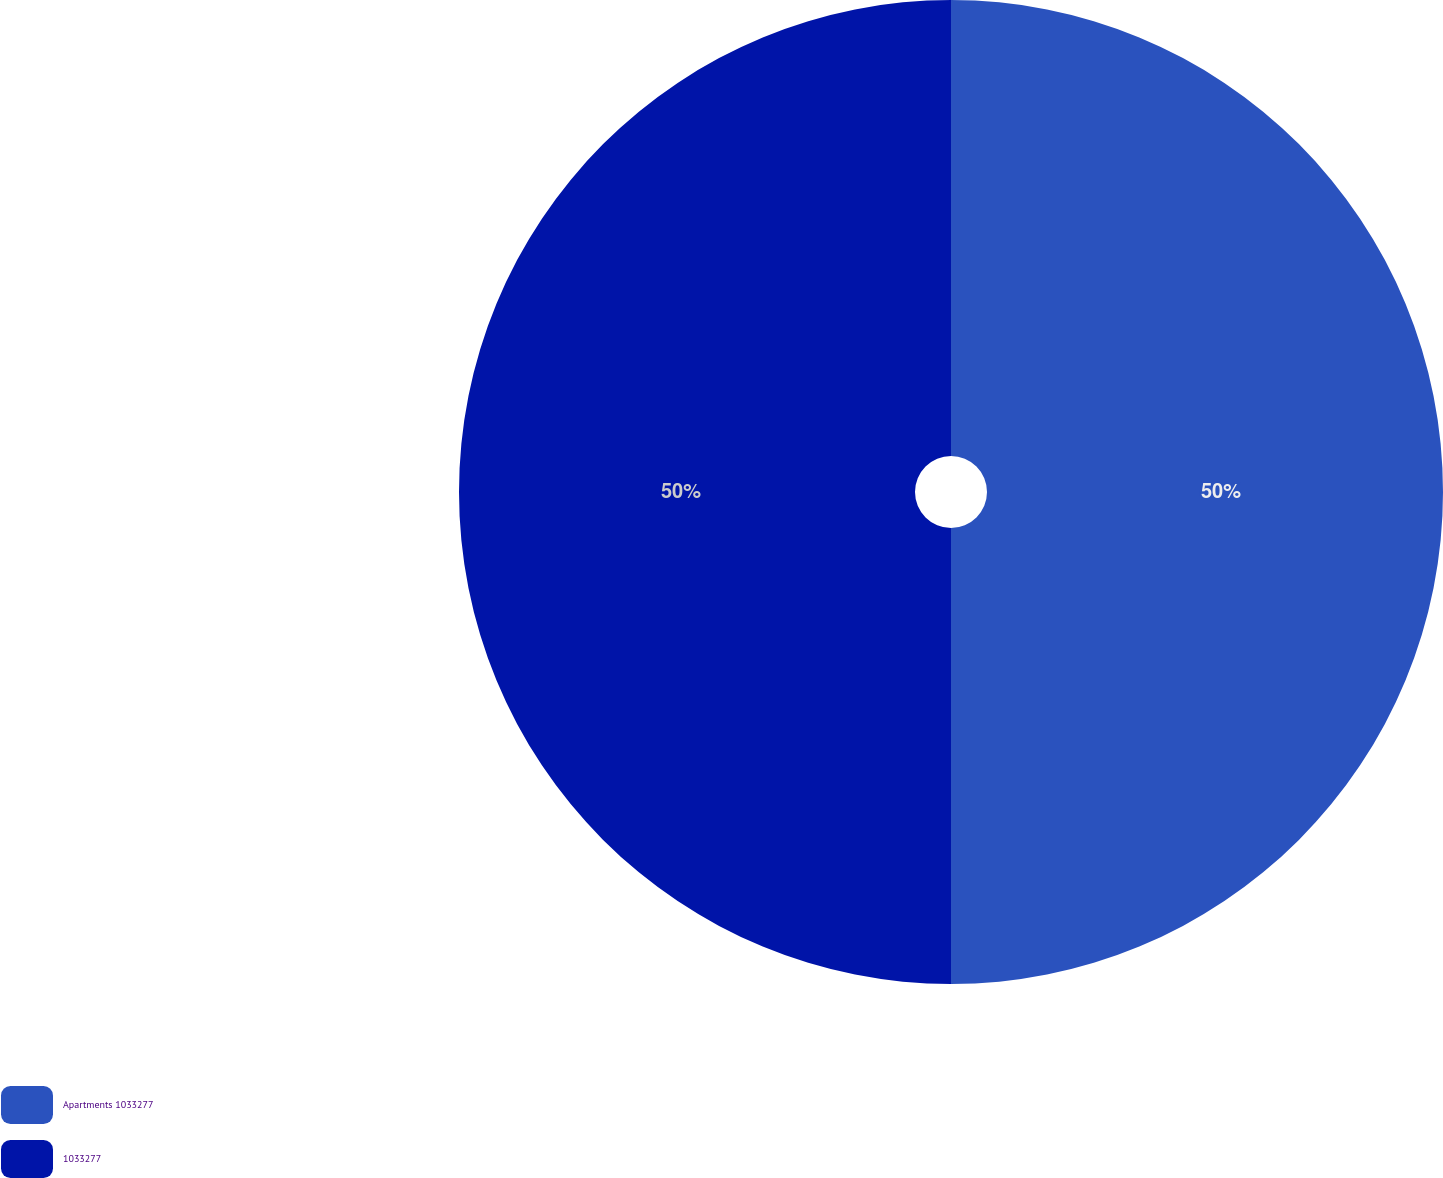Convert chart. <chart><loc_0><loc_0><loc_500><loc_500><pie_chart><fcel>Apartments 1033277<fcel>1033277<nl><fcel>50.0%<fcel>50.0%<nl></chart> 